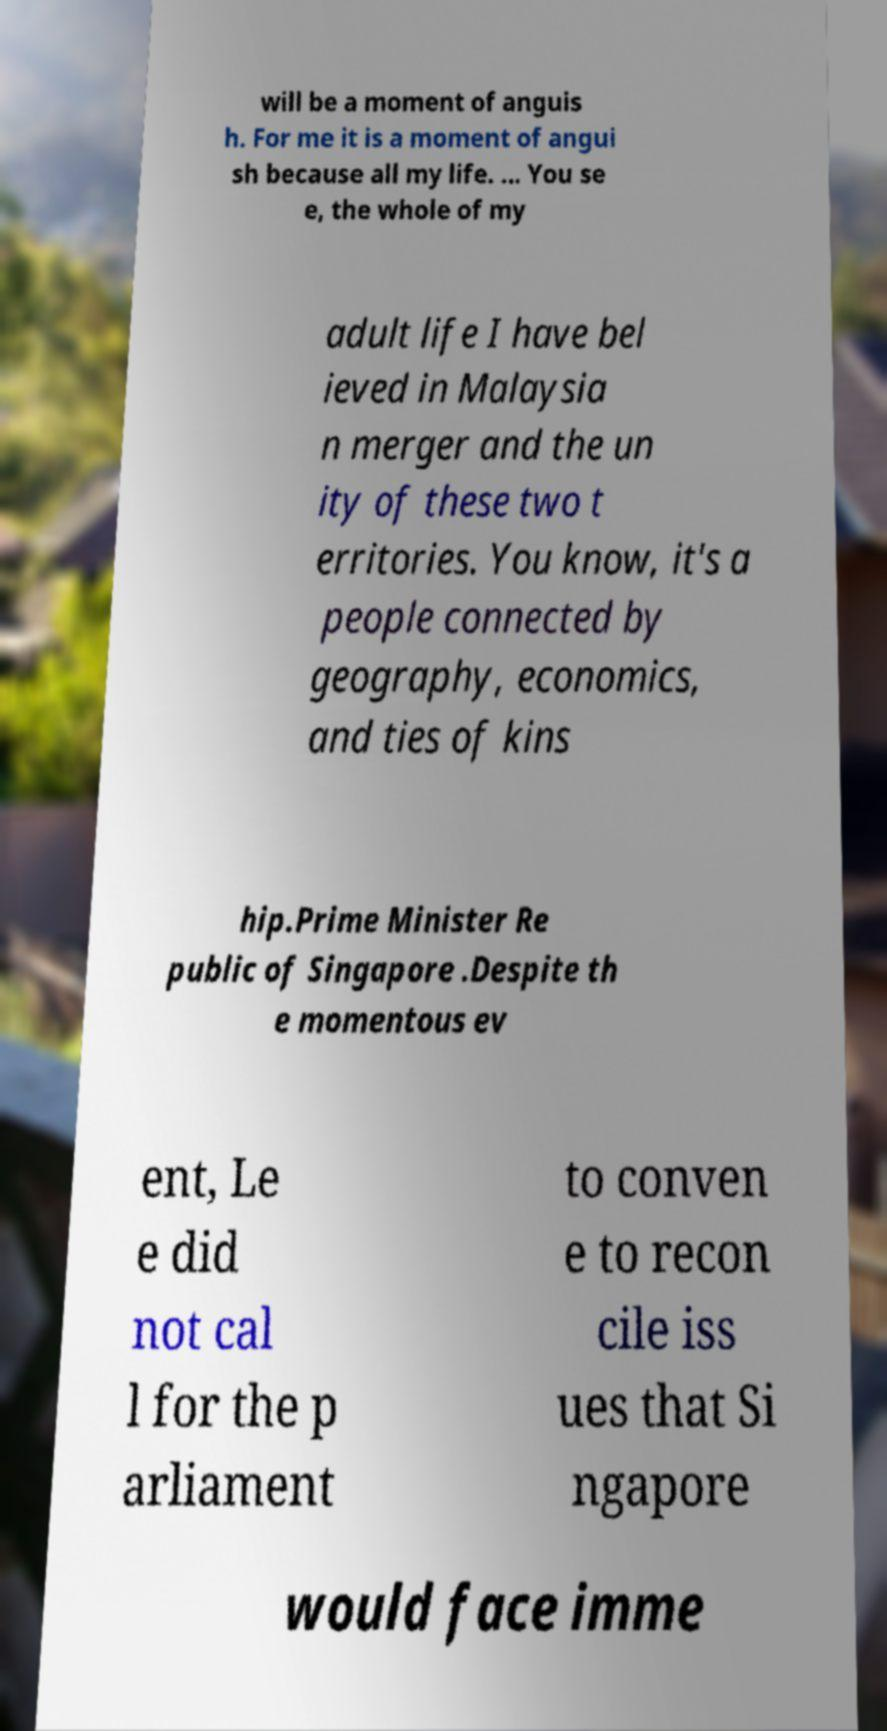Can you read and provide the text displayed in the image?This photo seems to have some interesting text. Can you extract and type it out for me? will be a moment of anguis h. For me it is a moment of angui sh because all my life. ... You se e, the whole of my adult life I have bel ieved in Malaysia n merger and the un ity of these two t erritories. You know, it's a people connected by geography, economics, and ties of kins hip.Prime Minister Re public of Singapore .Despite th e momentous ev ent, Le e did not cal l for the p arliament to conven e to recon cile iss ues that Si ngapore would face imme 